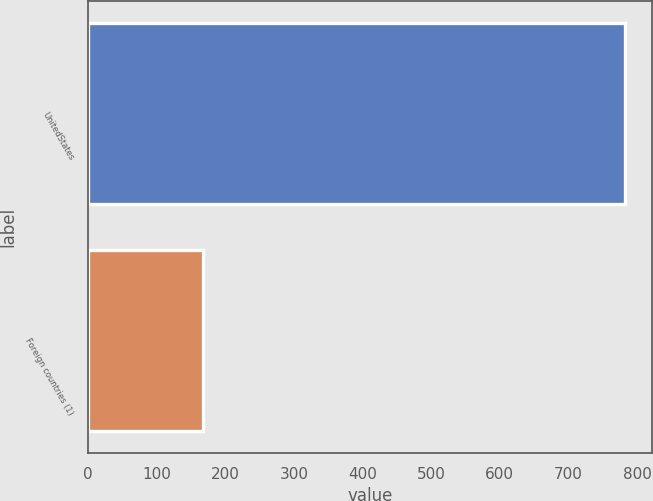Convert chart. <chart><loc_0><loc_0><loc_500><loc_500><bar_chart><fcel>UnitedStates<fcel>Foreign countries (1)<nl><fcel>782<fcel>167<nl></chart> 